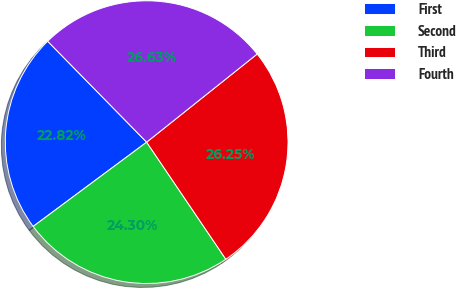<chart> <loc_0><loc_0><loc_500><loc_500><pie_chart><fcel>First<fcel>Second<fcel>Third<fcel>Fourth<nl><fcel>22.82%<fcel>24.3%<fcel>26.25%<fcel>26.63%<nl></chart> 